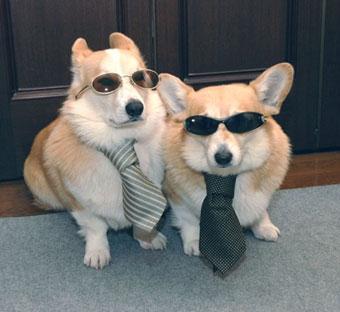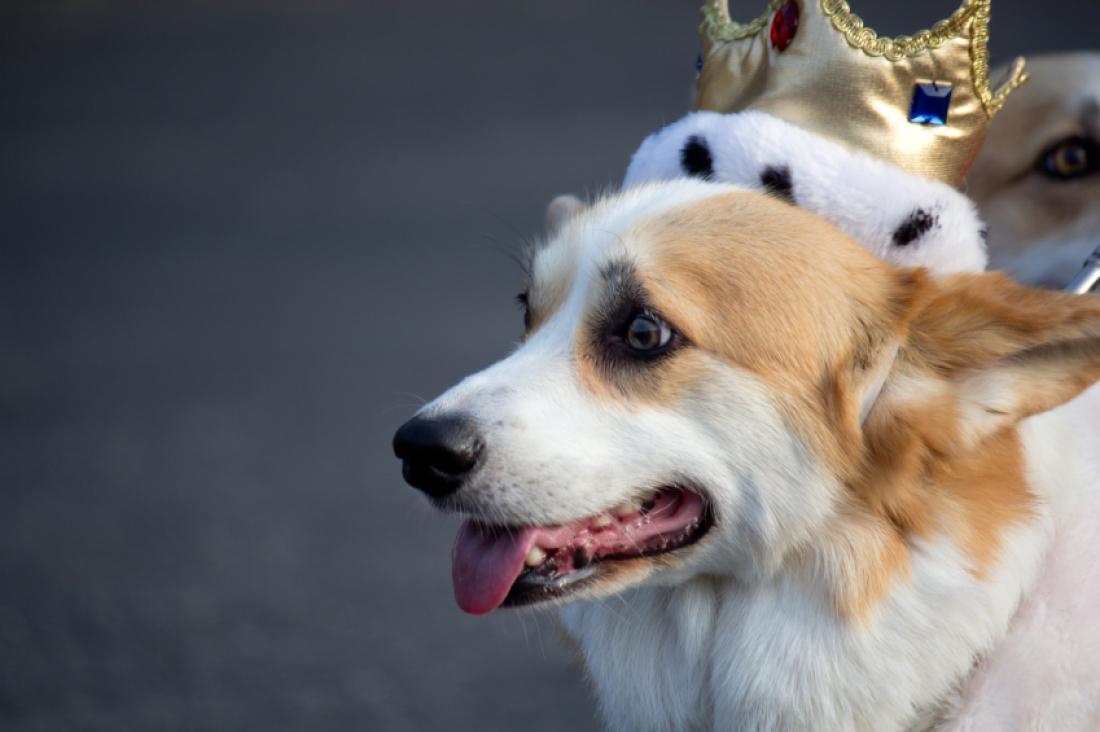The first image is the image on the left, the second image is the image on the right. Analyze the images presented: Is the assertion "There is one Corgi on a leash." valid? Answer yes or no. No. The first image is the image on the left, the second image is the image on the right. Analyze the images presented: Is the assertion "The dog in the image on the right is on a leasch" valid? Answer yes or no. No. 